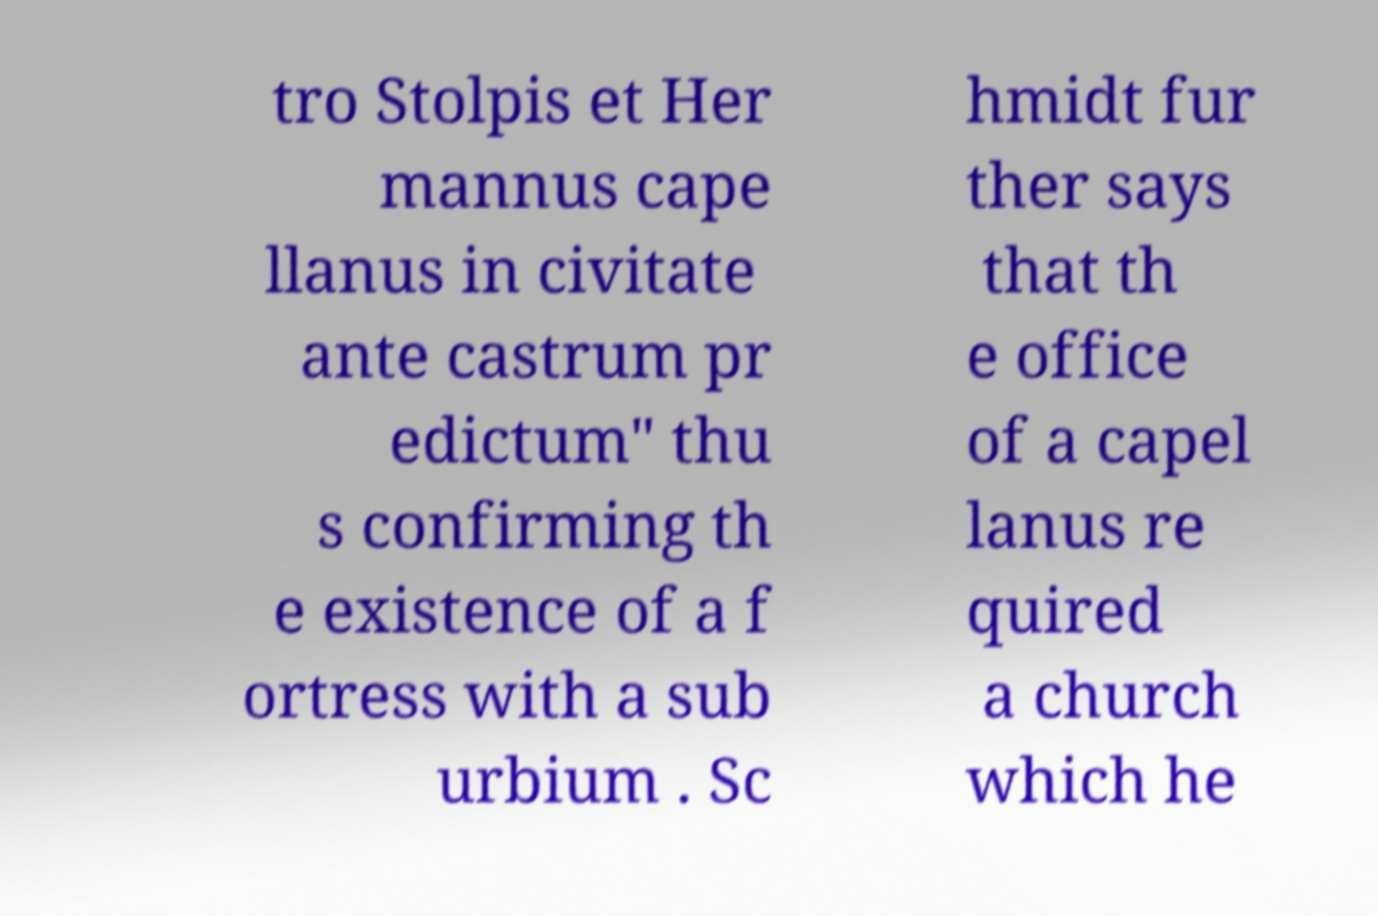Could you extract and type out the text from this image? tro Stolpis et Her mannus cape llanus in civitate ante castrum pr edictum" thu s confirming th e existence of a f ortress with a sub urbium . Sc hmidt fur ther says that th e office of a capel lanus re quired a church which he 